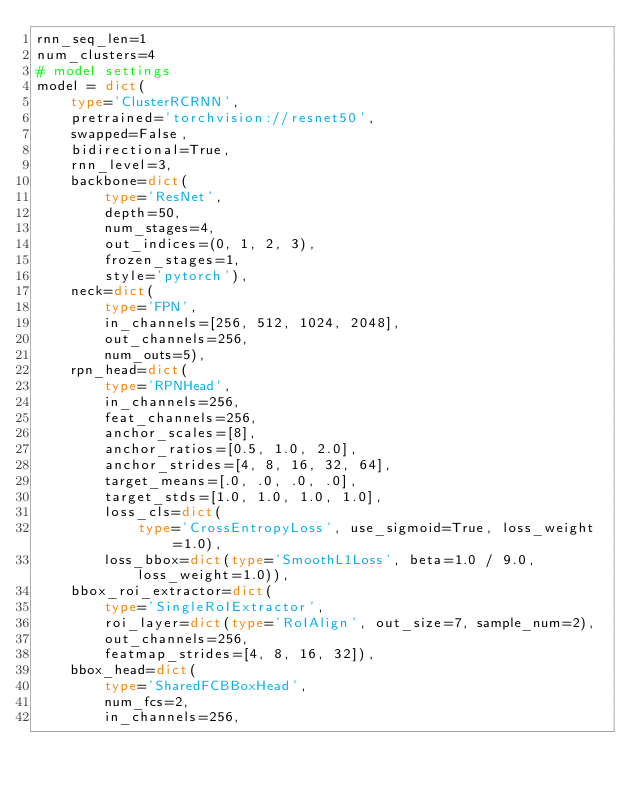Convert code to text. <code><loc_0><loc_0><loc_500><loc_500><_Python_>rnn_seq_len=1
num_clusters=4
# model settings
model = dict(
    type='ClusterRCRNN',
    pretrained='torchvision://resnet50',
    swapped=False,
    bidirectional=True,
    rnn_level=3,
    backbone=dict(
        type='ResNet',
        depth=50,
        num_stages=4,
        out_indices=(0, 1, 2, 3),
        frozen_stages=1,
        style='pytorch'),
    neck=dict(
        type='FPN',
        in_channels=[256, 512, 1024, 2048],
        out_channels=256,
        num_outs=5),
    rpn_head=dict(
        type='RPNHead',
        in_channels=256,
        feat_channels=256,
        anchor_scales=[8],
        anchor_ratios=[0.5, 1.0, 2.0],
        anchor_strides=[4, 8, 16, 32, 64],
        target_means=[.0, .0, .0, .0],
        target_stds=[1.0, 1.0, 1.0, 1.0],
        loss_cls=dict(
            type='CrossEntropyLoss', use_sigmoid=True, loss_weight=1.0),
        loss_bbox=dict(type='SmoothL1Loss', beta=1.0 / 9.0, loss_weight=1.0)),
    bbox_roi_extractor=dict(
        type='SingleRoIExtractor',
        roi_layer=dict(type='RoIAlign', out_size=7, sample_num=2),
        out_channels=256,
        featmap_strides=[4, 8, 16, 32]),
    bbox_head=dict(
        type='SharedFCBBoxHead',
        num_fcs=2,
        in_channels=256,</code> 